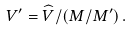Convert formula to latex. <formula><loc_0><loc_0><loc_500><loc_500>V ^ { \prime } = \widehat { V } / \left ( M / M ^ { \prime } \right ) .</formula> 